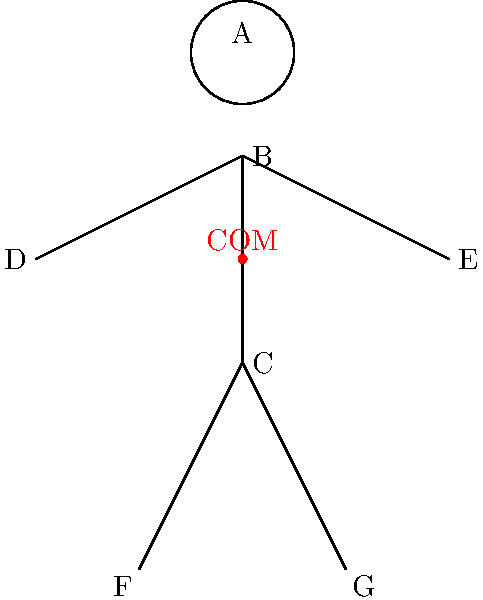In the "Mountain Pose" (Tadasana) stick figure shown above, the center of mass (COM) is marked. If the mass of the head (A) is 8 kg, each arm (BD and BE) is 4 kg, the torso (BC) is 30 kg, and each leg (CF and CG) is 12 kg, calculate the y-coordinate of the COM relative to the feet. Assume the COM of each body part is at its midpoint. Let's approach this step-by-step:

1) First, we need to determine the y-coordinates of each body part's COM:
   - Head (A): 5 units
   - Arms (BD and BE): 3.5 units
   - Torso (BC): 3 units
   - Legs (CF and CG): 1 unit

2) Now, we can use the formula for the center of mass:

   $$ y_{COM} = \frac{\sum m_i y_i}{\sum m_i} $$

   Where $m_i$ is the mass of each part and $y_i$ is its y-coordinate.

3) Let's calculate the numerator:
   $$ \sum m_i y_i = (8 \times 5) + (4 \times 3.5) + (4 \times 3.5) + (30 \times 3) + (12 \times 1) + (12 \times 1) $$
   $$ = 40 + 14 + 14 + 90 + 12 + 12 = 182 \text{ kg·units} $$

4) Now the denominator:
   $$ \sum m_i = 8 + 4 + 4 + 30 + 12 + 12 = 70 \text{ kg} $$

5) Finally, we can calculate $y_{COM}$:
   $$ y_{COM} = \frac{182}{70} = 2.6 \text{ units} $$

Therefore, the y-coordinate of the center of mass is 2.6 units above the feet.
Answer: 2.6 units 